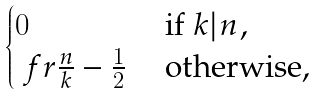Convert formula to latex. <formula><loc_0><loc_0><loc_500><loc_500>\begin{cases} 0 & \text { if } k | n , \\ \ f r { \frac { n } { k } } - \frac { 1 } { 2 } & \text { otherwise, } \end{cases}</formula> 